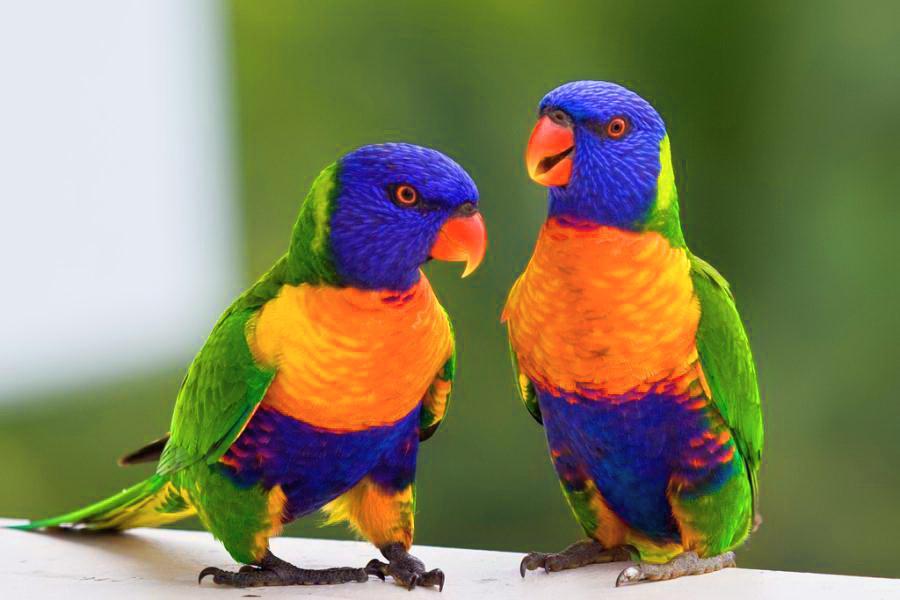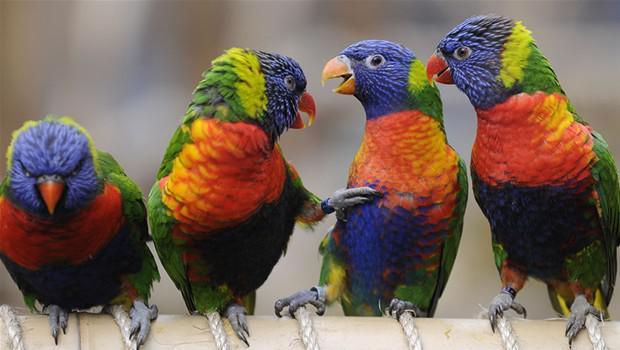The first image is the image on the left, the second image is the image on the right. Evaluate the accuracy of this statement regarding the images: "Four colorful birds are perched outside.". Is it true? Answer yes or no. No. The first image is the image on the left, the second image is the image on the right. Assess this claim about the two images: "Each image contains one pair of multicolor parrots.". Correct or not? Answer yes or no. No. 